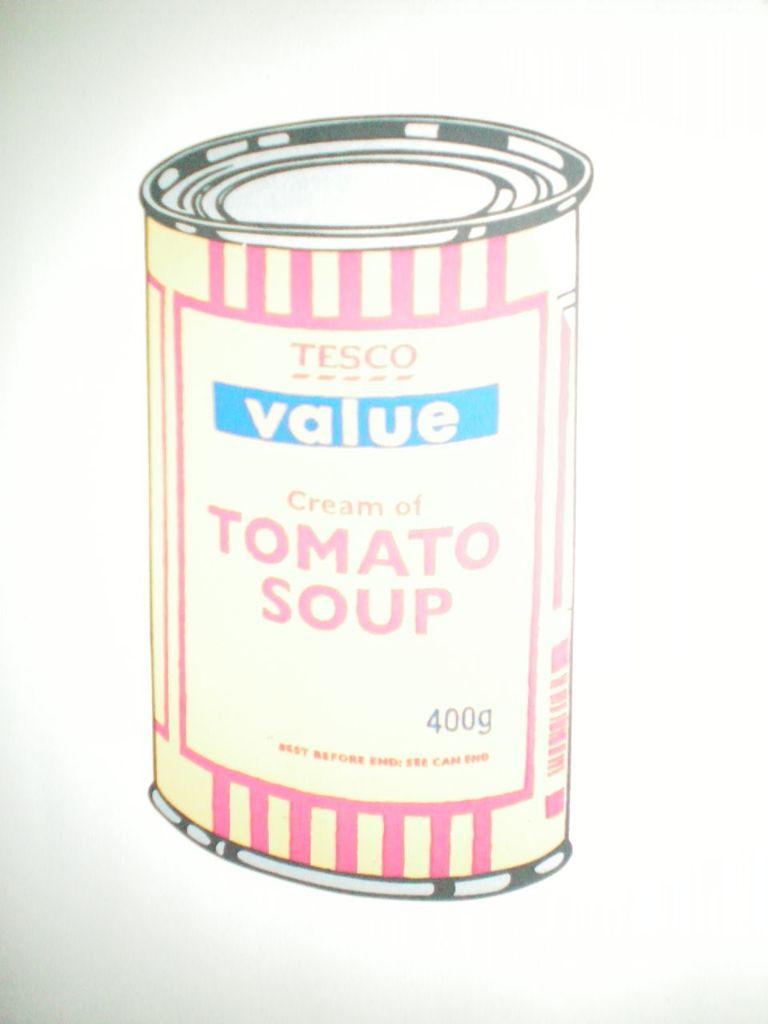What kind of soup is in this can?
Give a very brief answer. Tomato. 